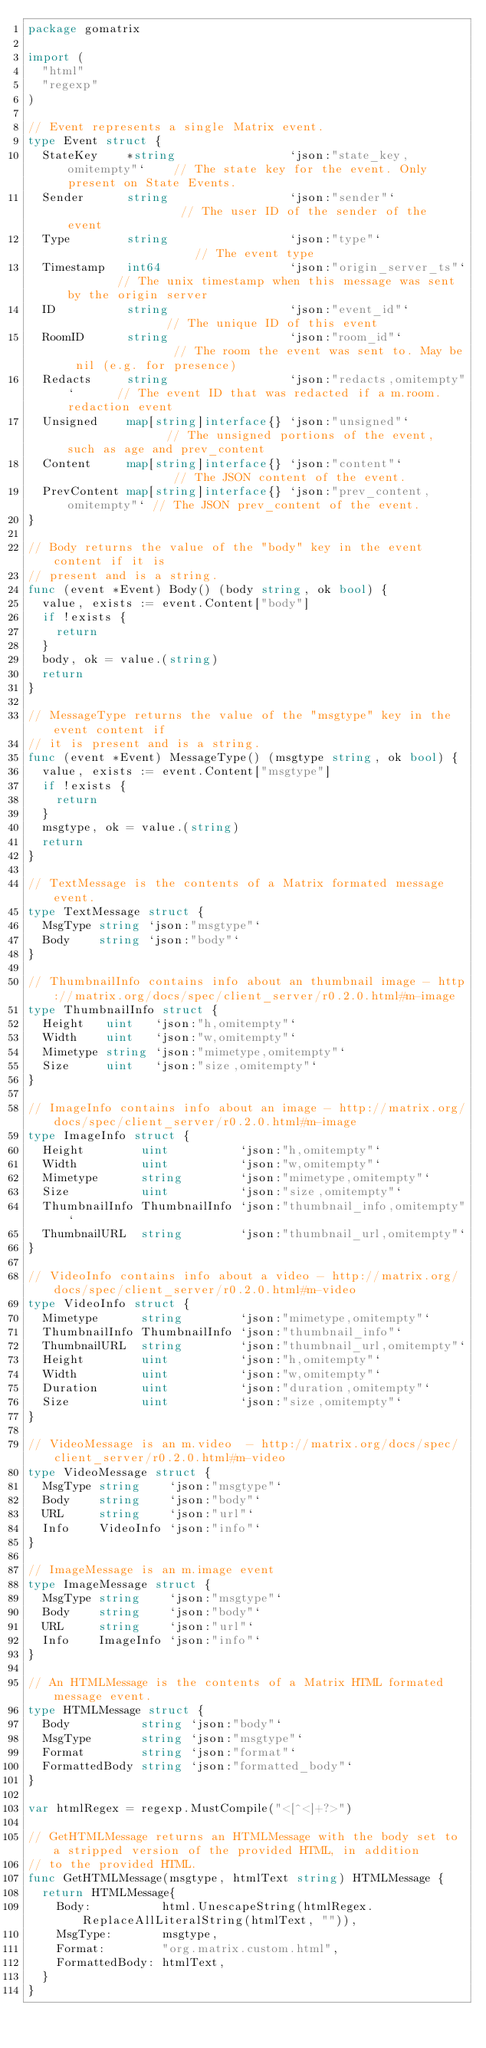Convert code to text. <code><loc_0><loc_0><loc_500><loc_500><_Go_>package gomatrix

import (
	"html"
	"regexp"
)

// Event represents a single Matrix event.
type Event struct {
	StateKey    *string                `json:"state_key,omitempty"`    // The state key for the event. Only present on State Events.
	Sender      string                 `json:"sender"`                 // The user ID of the sender of the event
	Type        string                 `json:"type"`                   // The event type
	Timestamp   int64                  `json:"origin_server_ts"`       // The unix timestamp when this message was sent by the origin server
	ID          string                 `json:"event_id"`               // The unique ID of this event
	RoomID      string                 `json:"room_id"`                // The room the event was sent to. May be nil (e.g. for presence)
	Redacts     string                 `json:"redacts,omitempty"`      // The event ID that was redacted if a m.room.redaction event
	Unsigned    map[string]interface{} `json:"unsigned"`               // The unsigned portions of the event, such as age and prev_content
	Content     map[string]interface{} `json:"content"`                // The JSON content of the event.
	PrevContent map[string]interface{} `json:"prev_content,omitempty"` // The JSON prev_content of the event.
}

// Body returns the value of the "body" key in the event content if it is
// present and is a string.
func (event *Event) Body() (body string, ok bool) {
	value, exists := event.Content["body"]
	if !exists {
		return
	}
	body, ok = value.(string)
	return
}

// MessageType returns the value of the "msgtype" key in the event content if
// it is present and is a string.
func (event *Event) MessageType() (msgtype string, ok bool) {
	value, exists := event.Content["msgtype"]
	if !exists {
		return
	}
	msgtype, ok = value.(string)
	return
}

// TextMessage is the contents of a Matrix formated message event.
type TextMessage struct {
	MsgType string `json:"msgtype"`
	Body    string `json:"body"`
}

// ThumbnailInfo contains info about an thumbnail image - http://matrix.org/docs/spec/client_server/r0.2.0.html#m-image
type ThumbnailInfo struct {
	Height   uint   `json:"h,omitempty"`
	Width    uint   `json:"w,omitempty"`
	Mimetype string `json:"mimetype,omitempty"`
	Size     uint   `json:"size,omitempty"`
}

// ImageInfo contains info about an image - http://matrix.org/docs/spec/client_server/r0.2.0.html#m-image
type ImageInfo struct {
	Height        uint          `json:"h,omitempty"`
	Width         uint          `json:"w,omitempty"`
	Mimetype      string        `json:"mimetype,omitempty"`
	Size          uint          `json:"size,omitempty"`
	ThumbnailInfo ThumbnailInfo `json:"thumbnail_info,omitempty"`
	ThumbnailURL  string        `json:"thumbnail_url,omitempty"`
}

// VideoInfo contains info about a video - http://matrix.org/docs/spec/client_server/r0.2.0.html#m-video
type VideoInfo struct {
	Mimetype      string        `json:"mimetype,omitempty"`
	ThumbnailInfo ThumbnailInfo `json:"thumbnail_info"`
	ThumbnailURL  string        `json:"thumbnail_url,omitempty"`
	Height        uint          `json:"h,omitempty"`
	Width         uint          `json:"w,omitempty"`
	Duration      uint          `json:"duration,omitempty"`
	Size          uint          `json:"size,omitempty"`
}

// VideoMessage is an m.video  - http://matrix.org/docs/spec/client_server/r0.2.0.html#m-video
type VideoMessage struct {
	MsgType string    `json:"msgtype"`
	Body    string    `json:"body"`
	URL     string    `json:"url"`
	Info    VideoInfo `json:"info"`
}

// ImageMessage is an m.image event
type ImageMessage struct {
	MsgType string    `json:"msgtype"`
	Body    string    `json:"body"`
	URL     string    `json:"url"`
	Info    ImageInfo `json:"info"`
}

// An HTMLMessage is the contents of a Matrix HTML formated message event.
type HTMLMessage struct {
	Body          string `json:"body"`
	MsgType       string `json:"msgtype"`
	Format        string `json:"format"`
	FormattedBody string `json:"formatted_body"`
}

var htmlRegex = regexp.MustCompile("<[^<]+?>")

// GetHTMLMessage returns an HTMLMessage with the body set to a stripped version of the provided HTML, in addition
// to the provided HTML.
func GetHTMLMessage(msgtype, htmlText string) HTMLMessage {
	return HTMLMessage{
		Body:          html.UnescapeString(htmlRegex.ReplaceAllLiteralString(htmlText, "")),
		MsgType:       msgtype,
		Format:        "org.matrix.custom.html",
		FormattedBody: htmlText,
	}
}
</code> 